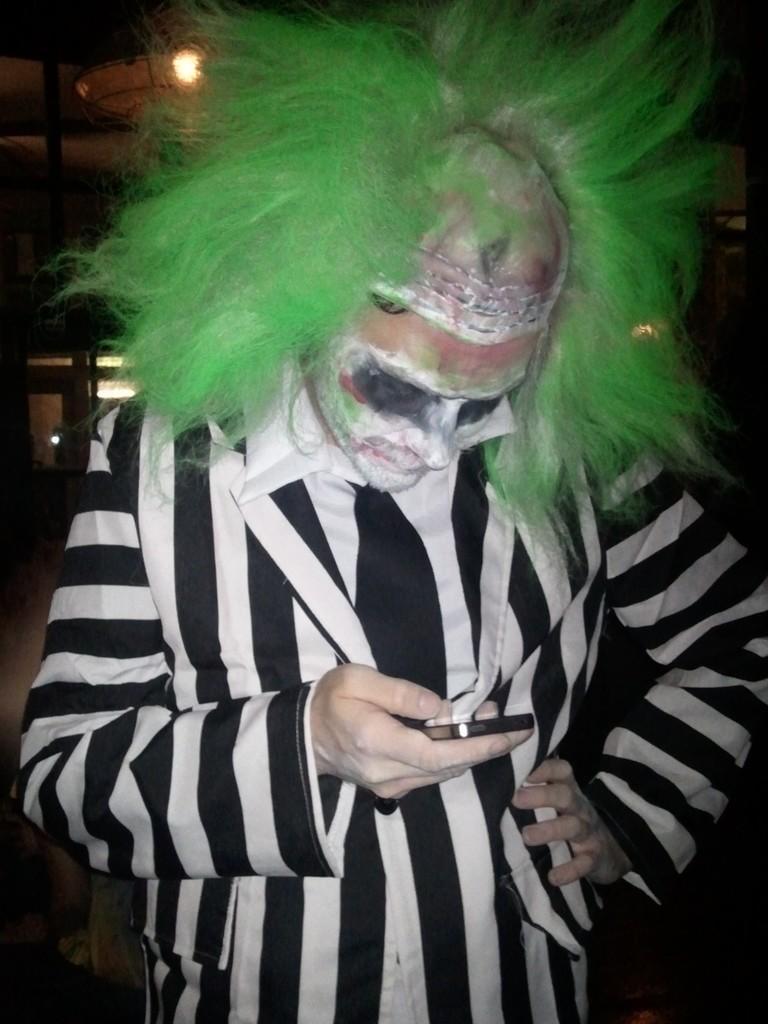Could you give a brief overview of what you see in this image? Here in this picture we can see a person standing over a place and we can see he is holding a mobile phone and seeing it and he is wearing a black and white colored coat on him and wearing a clown makeup and mask on him. 